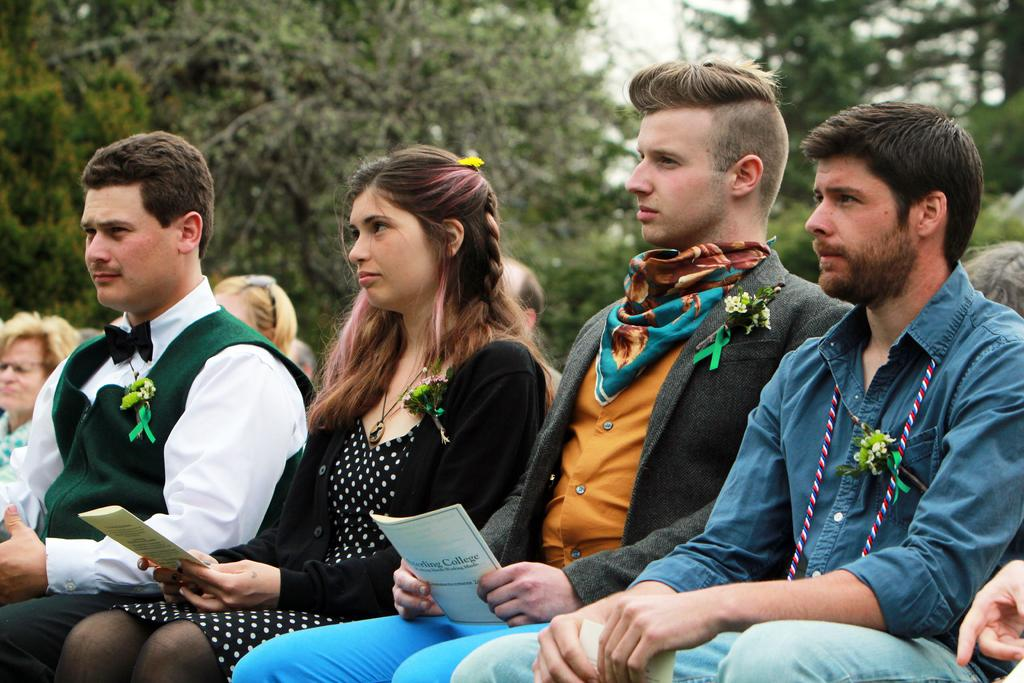What are the people in the image doing? The people in the image are sitting and holding papers. What might the people be discussing or working on? It is not clear from the image what the people are discussing or working on, but their holding of papers suggests they might be engaged in a meeting or reviewing documents. Can you describe the background of the image? The background of the image is blurry, but trees are visible in the background. What type of pencil is being used by the person in the image? There is no pencil visible in the image; the people are holding papers, but no writing utensils are present. 